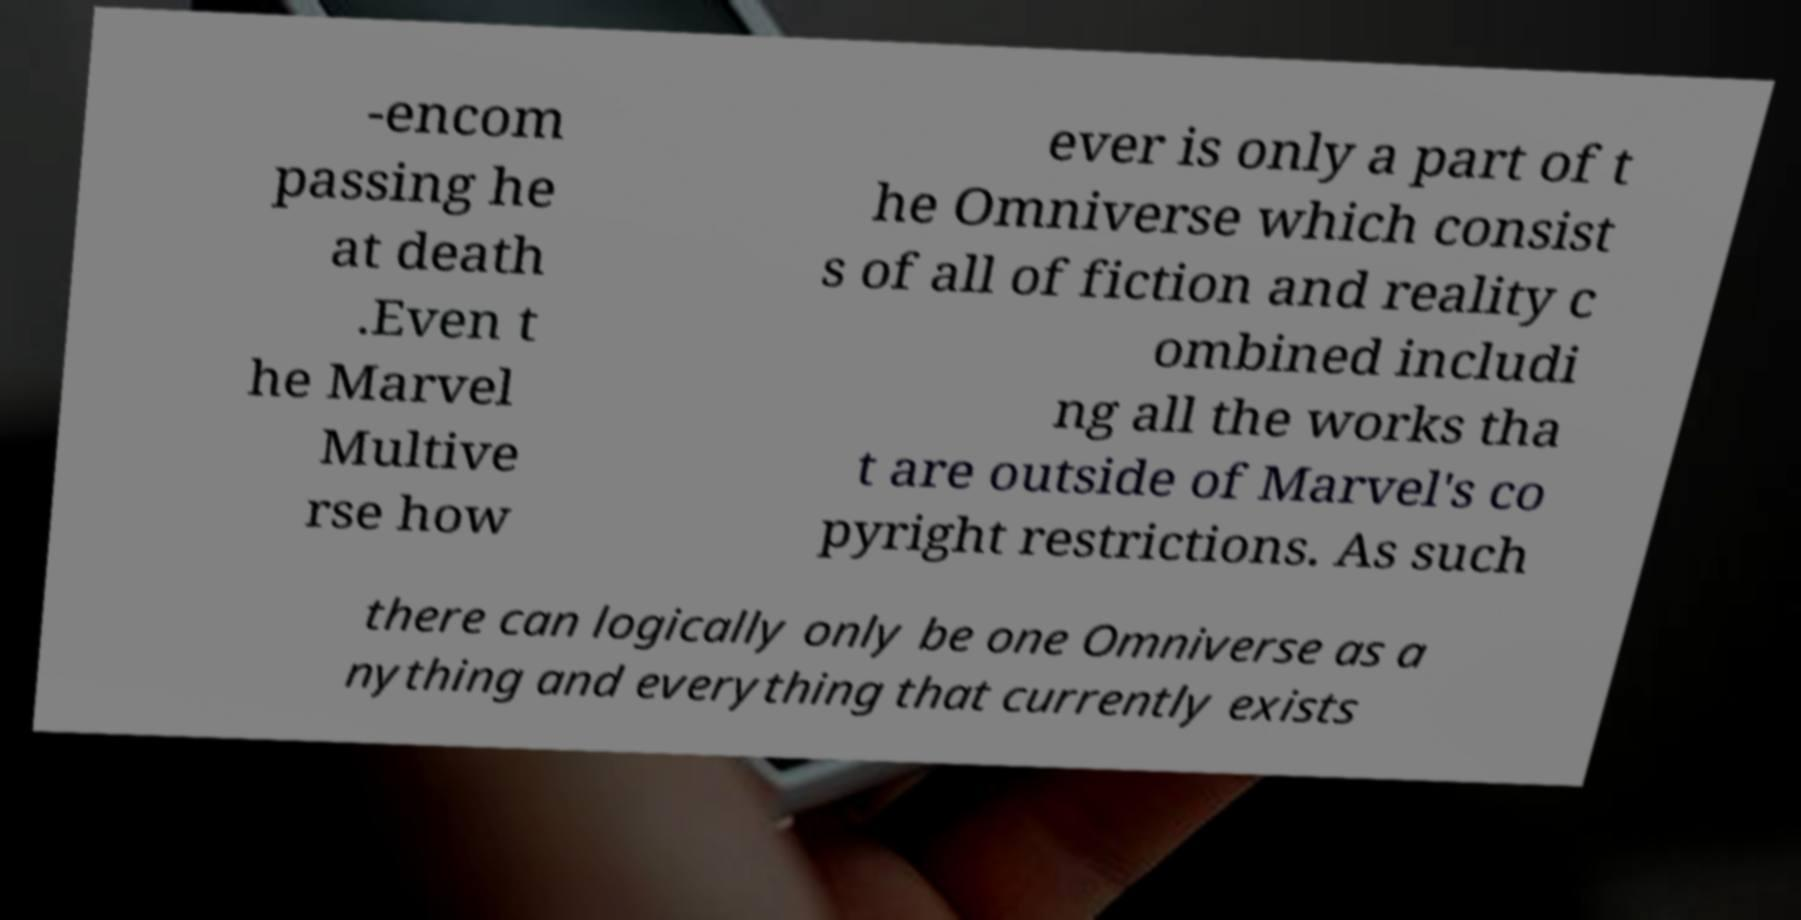Could you assist in decoding the text presented in this image and type it out clearly? -encom passing he at death .Even t he Marvel Multive rse how ever is only a part of t he Omniverse which consist s of all of fiction and reality c ombined includi ng all the works tha t are outside of Marvel's co pyright restrictions. As such there can logically only be one Omniverse as a nything and everything that currently exists 